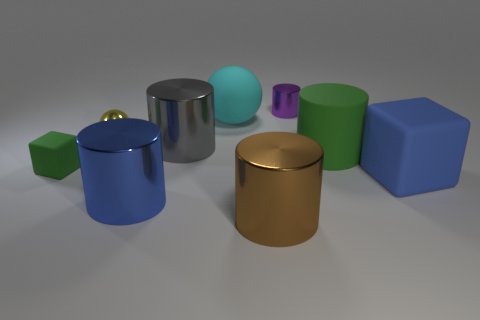What shape is the big rubber thing that is the same color as the small rubber object?
Your answer should be very brief. Cylinder. How many tiny objects have the same color as the matte cylinder?
Your answer should be very brief. 1. Is there a cyan metallic cylinder of the same size as the purple thing?
Give a very brief answer. No. What color is the big rubber cube?
Your answer should be very brief. Blue. Do the cyan rubber sphere and the purple metallic cylinder have the same size?
Offer a terse response. No. What number of objects are either big blue shiny objects or gray shiny objects?
Your answer should be very brief. 2. Are there an equal number of tiny yellow objects right of the big gray metal object and big blue metal balls?
Offer a terse response. Yes. Is there a green matte thing that is in front of the green cylinder right of the cube that is to the left of the large matte block?
Make the answer very short. Yes. The big cube that is the same material as the large green object is what color?
Make the answer very short. Blue. There is a tiny shiny object in front of the small purple shiny object; is its color the same as the big block?
Provide a short and direct response. No. 